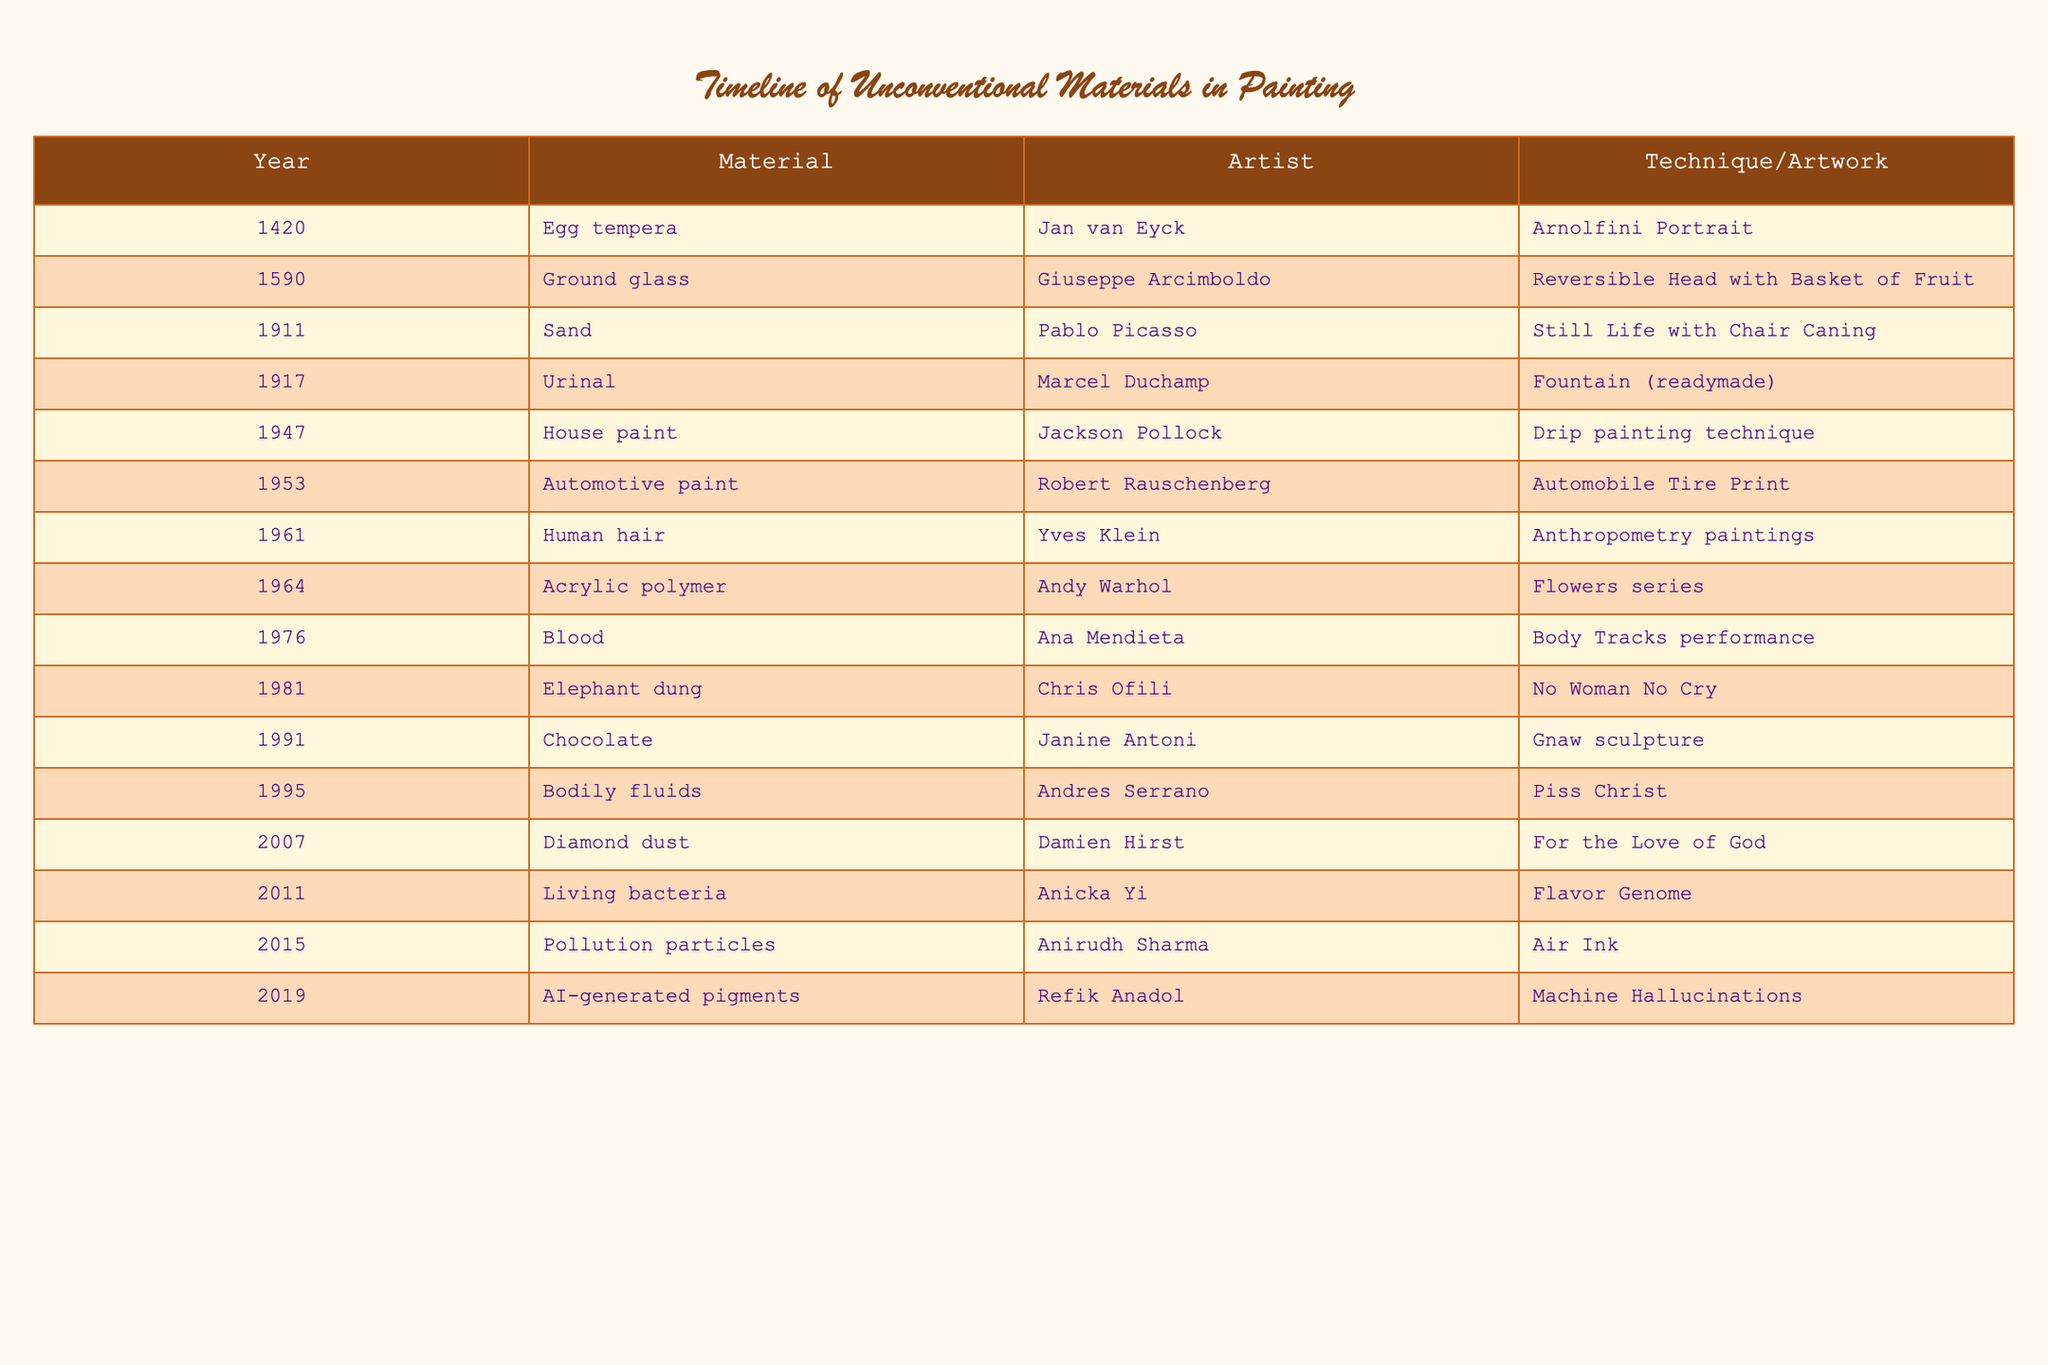What year marked the use of blood as a painting material? The table indicates that the use of blood as a material occurred in 1976. We can directly find this by looking for "Blood" under the Material column and noting the corresponding year.
Answer: 1976 Which unconventional material was first used in the timeline? Upon checking the table, the earliest unconventional material is egg tempera used by Jan van Eyck in 1420. This can be confirmed by reviewing the years listed and identifying the first one.
Answer: Egg tempera How many different unconventional materials were used by artists in the 20th century? The 20th century in the table includes the following materials: sand (1911), urinal (1917), house paint (1947), automotive paint (1953), human hair (1961), and blood (1976). Counting these provides a total of 6 unique materials.
Answer: 6 Did any artist use chocolate as a painting material? Yes, the table shows Janine Antoni used chocolate in her artwork "Gnaw sculpture" in 1991. This is verifiable by looking for "Chocolate" in the Material column and confirming the associated artist.
Answer: Yes Which material used by Damien Hirst in 2007 gained attention due to its luxury association? The table lists diamond dust as the material used by Damien Hirst in 2007. This material is known for its luxury and uniqueness, making it differentiated among others listed.
Answer: Diamond dust What is the difference in years between the use of human hair and pollution particles as painting materials? Human hair was used in 1961 and pollution particles were used in 2015. Calculating the difference: 2015 - 1961 = 54 years. This gives a direct answer to the difference in use years.
Answer: 54 years In total, how many materials listed in the table are derived from animal or human biological elements? The biological elements include blood (1976), bodily fluids (1995), and human hair (1961). Adding these three gives a total of 3 materials that are biological in nature.
Answer: 3 Which artist utilized living bacteria in their work? Anicka Yi is the artist who used living bacteria in her artwork "Flavor Genome," and this information can be found by searching for "Living bacteria" in the Material column of the table.
Answer: Anicka Yi What material did Jackson Pollock use for his drip painting technique? The table shows that Jackson Pollock used house paint for his drip painting technique in 1947. This information can be retrieved directly from the table.
Answer: House paint 